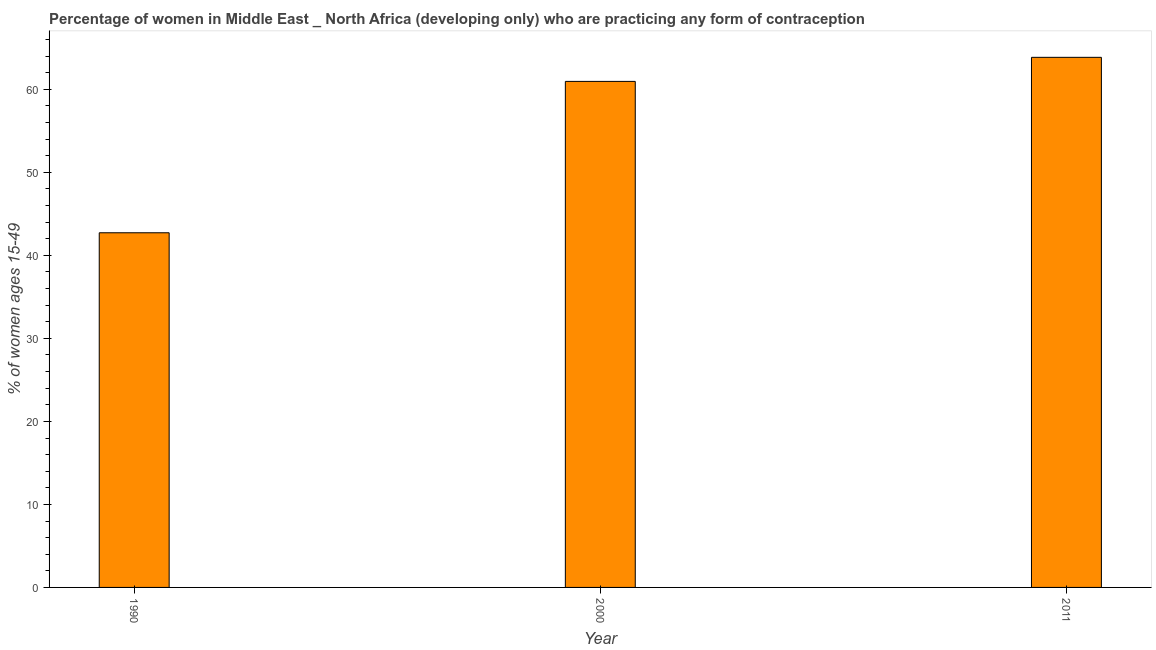What is the title of the graph?
Give a very brief answer. Percentage of women in Middle East _ North Africa (developing only) who are practicing any form of contraception. What is the label or title of the X-axis?
Keep it short and to the point. Year. What is the label or title of the Y-axis?
Give a very brief answer. % of women ages 15-49. What is the contraceptive prevalence in 2011?
Provide a succinct answer. 63.86. Across all years, what is the maximum contraceptive prevalence?
Your answer should be very brief. 63.86. Across all years, what is the minimum contraceptive prevalence?
Give a very brief answer. 42.72. In which year was the contraceptive prevalence maximum?
Provide a short and direct response. 2011. What is the sum of the contraceptive prevalence?
Your response must be concise. 167.54. What is the difference between the contraceptive prevalence in 1990 and 2011?
Your response must be concise. -21.13. What is the average contraceptive prevalence per year?
Provide a succinct answer. 55.85. What is the median contraceptive prevalence?
Provide a short and direct response. 60.96. Do a majority of the years between 1990 and 2000 (inclusive) have contraceptive prevalence greater than 54 %?
Give a very brief answer. No. What is the ratio of the contraceptive prevalence in 1990 to that in 2011?
Your answer should be very brief. 0.67. Is the contraceptive prevalence in 1990 less than that in 2011?
Offer a very short reply. Yes. What is the difference between the highest and the lowest contraceptive prevalence?
Your answer should be very brief. 21.13. How many bars are there?
Your answer should be compact. 3. Are all the bars in the graph horizontal?
Offer a very short reply. No. What is the difference between two consecutive major ticks on the Y-axis?
Your answer should be very brief. 10. What is the % of women ages 15-49 of 1990?
Make the answer very short. 42.72. What is the % of women ages 15-49 in 2000?
Your answer should be very brief. 60.96. What is the % of women ages 15-49 in 2011?
Offer a very short reply. 63.86. What is the difference between the % of women ages 15-49 in 1990 and 2000?
Offer a very short reply. -18.23. What is the difference between the % of women ages 15-49 in 1990 and 2011?
Provide a succinct answer. -21.13. What is the difference between the % of women ages 15-49 in 2000 and 2011?
Offer a terse response. -2.9. What is the ratio of the % of women ages 15-49 in 1990 to that in 2000?
Your answer should be compact. 0.7. What is the ratio of the % of women ages 15-49 in 1990 to that in 2011?
Provide a short and direct response. 0.67. What is the ratio of the % of women ages 15-49 in 2000 to that in 2011?
Make the answer very short. 0.95. 